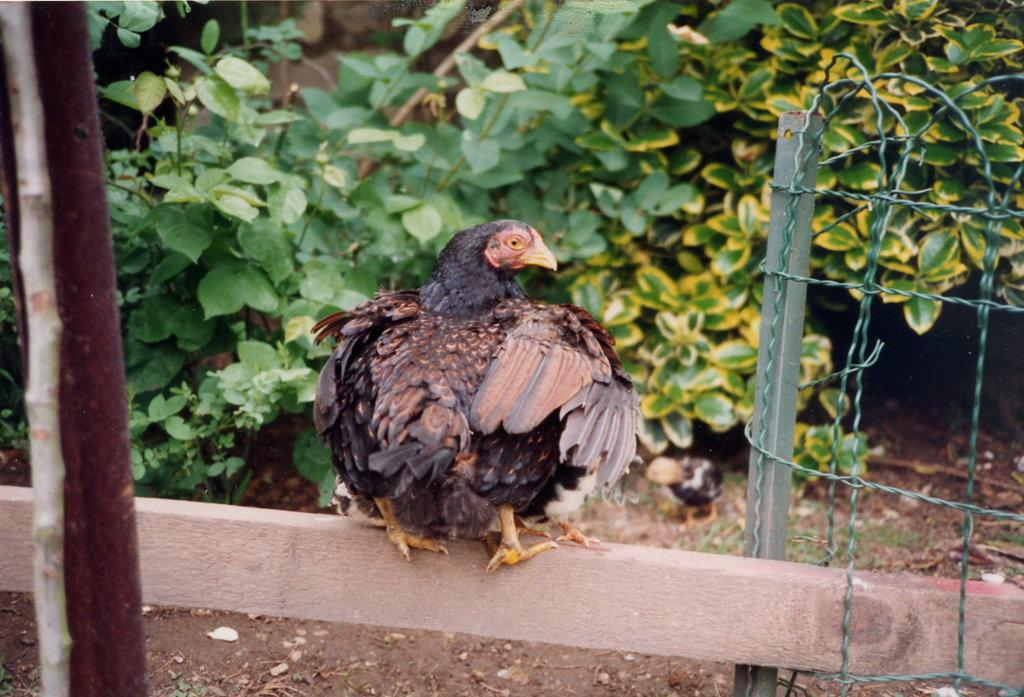What is the bird perched on in the image? The bird is on an object in the image. What else can be seen in the image besides the bird? There are wires, plants, rods, and other objects visible in the image. Can you describe the wires in the image? Yes, there are wires visible in the image. What type of objects are present in the image? There are plants and rods, as well as other objects, in the image. What is the bird's role in the society depicted in the image? The image does not depict a society, and therefore the bird's role in any society cannot be determined. 